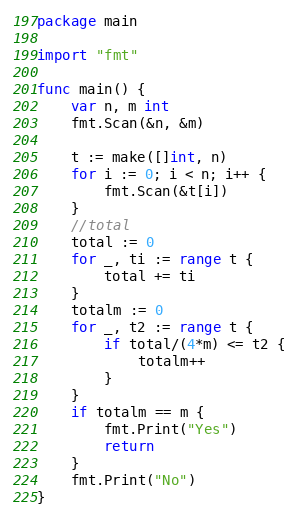Convert code to text. <code><loc_0><loc_0><loc_500><loc_500><_Go_>package main

import "fmt"

func main() {
	var n, m int
	fmt.Scan(&n, &m)

	t := make([]int, n)
	for i := 0; i < n; i++ {
		fmt.Scan(&t[i])
	}
	//total
	total := 0
	for _, ti := range t {
		total += ti
	}
	totalm := 0
	for _, t2 := range t {
		if total/(4*m) <= t2 {
			totalm++
		}
	}
	if totalm == m {
		fmt.Print("Yes")
		return
	}
	fmt.Print("No")
}
</code> 